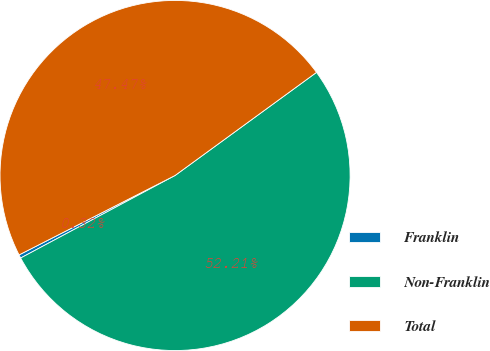Convert chart to OTSL. <chart><loc_0><loc_0><loc_500><loc_500><pie_chart><fcel>Franklin<fcel>Non-Franklin<fcel>Total<nl><fcel>0.32%<fcel>52.21%<fcel>47.47%<nl></chart> 